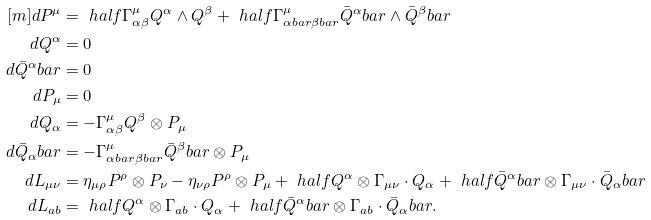<formula> <loc_0><loc_0><loc_500><loc_500>[ m ] d P ^ { \mu } & = \ h a l f \Gamma ^ { \mu } _ { \alpha \beta } Q ^ { \alpha } \wedge Q ^ { \beta } + \ h a l f \Gamma ^ { \mu } _ { \alpha b a r \beta b a r } \bar { Q } ^ { \alpha } b a r \wedge \bar { Q } ^ { \beta } b a r \\ d Q ^ { \alpha } & = 0 \\ d \bar { Q } ^ { \alpha } b a r & = 0 \\ d P _ { \mu } & = 0 \\ d Q _ { \alpha } & = - \Gamma ^ { \mu } _ { \alpha \beta } Q ^ { \beta } \otimes P _ { \mu } \\ d \bar { Q } _ { \alpha } b a r & = - \Gamma ^ { \mu } _ { \alpha b a r \beta b a r } \bar { Q } ^ { \beta } b a r \otimes P _ { \mu } \\ d L _ { \mu \nu } & = \eta _ { \mu \rho } P ^ { \rho } \otimes P _ { \nu } - \eta _ { \nu \rho } P ^ { \rho } \otimes P _ { \mu } + \ h a l f Q ^ { \alpha } \otimes \Gamma _ { \mu \nu } \cdot Q _ { \alpha } + \ h a l f \bar { Q } ^ { \alpha } b a r \otimes \Gamma _ { \mu \nu } \cdot \bar { Q } _ { \alpha } b a r \\ d L _ { a b } & = \ h a l f Q ^ { \alpha } \otimes \Gamma _ { a b } \cdot Q _ { \alpha } + \ h a l f \bar { Q } ^ { \alpha } b a r \otimes \Gamma _ { a b } \cdot \bar { Q } _ { \alpha } b a r .</formula> 